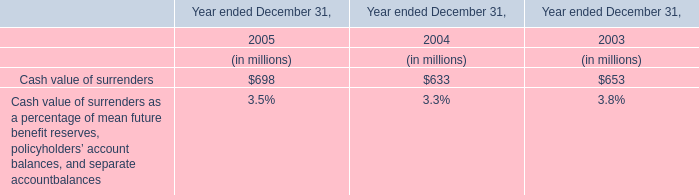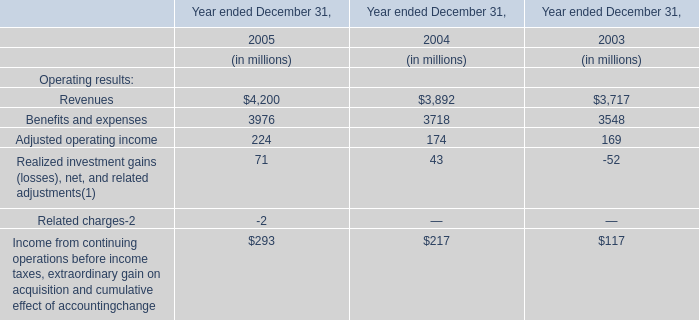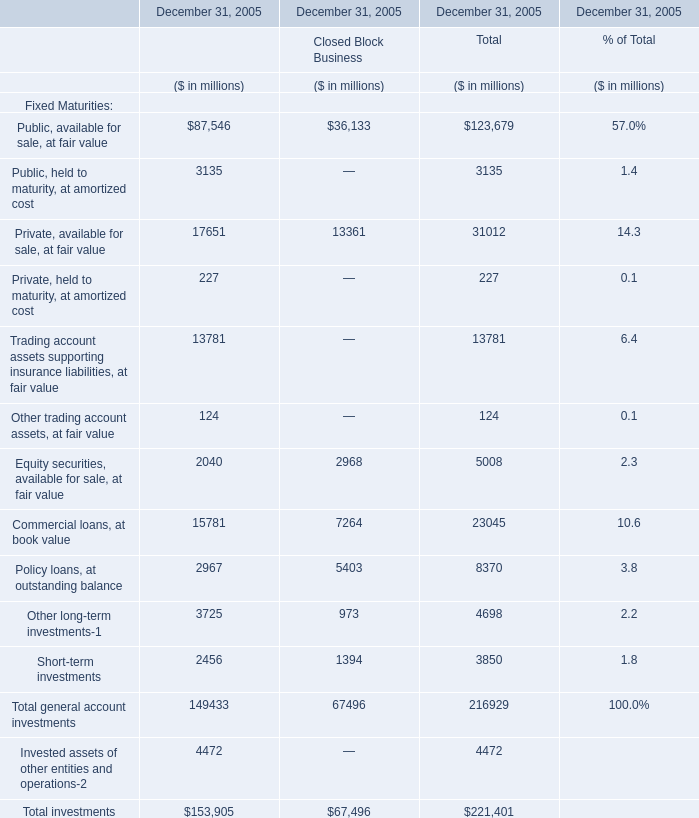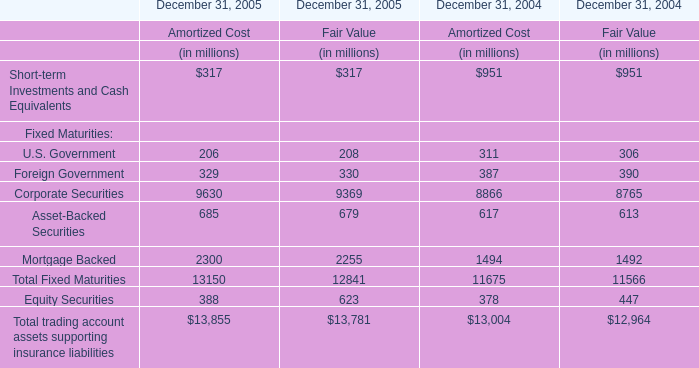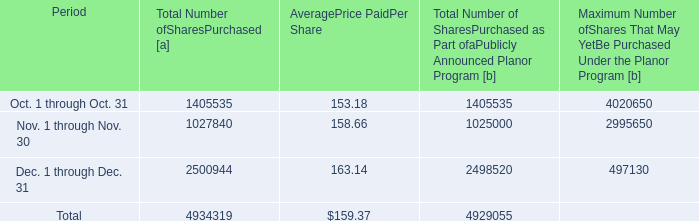What's the total amount of the Short-term investments for Fixed Maturities in the years where Cash value of surrenders is greater than 690? (in million) 
Computations: (2456 + 1394)
Answer: 3850.0. 